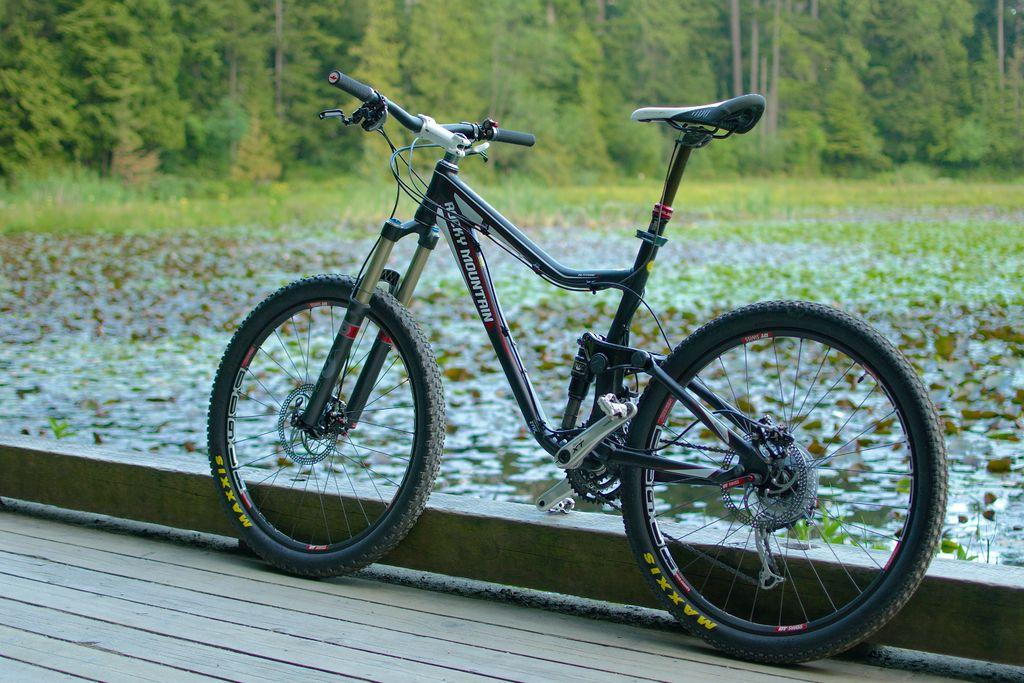What is the main object in the image? There is a bicycle in the image. What type of surface is the bicycle resting on? The bicycle is on a wooden floor. Is there any text or writing on the bicycle? Yes, there is text on the bicycle. What can be seen in the background of the image? There are trees visible in the background of the image. Can you describe the water in the image? There are plants on the water in the image. What flavor of ice cream does the monkey enjoy in the image? There is no monkey or ice cream present in the image. What hobbies does the person riding the bicycle have, based on the image? The image does not provide any information about the person riding the bicycle or their hobbies. 